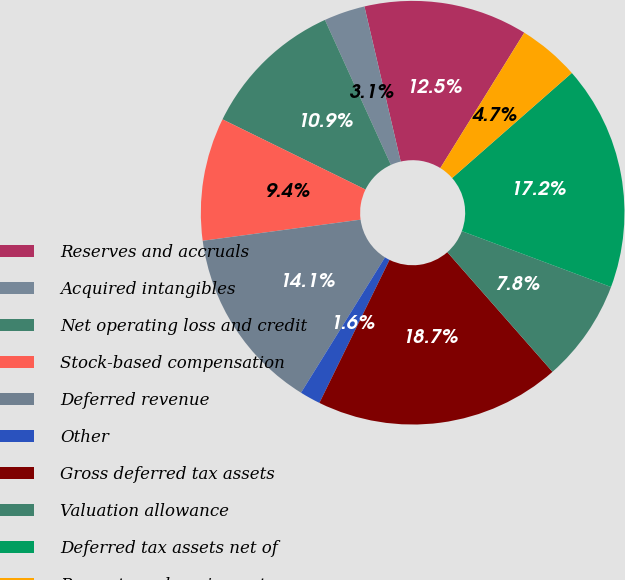Convert chart. <chart><loc_0><loc_0><loc_500><loc_500><pie_chart><fcel>Reserves and accruals<fcel>Acquired intangibles<fcel>Net operating loss and credit<fcel>Stock-based compensation<fcel>Deferred revenue<fcel>Other<fcel>Gross deferred tax assets<fcel>Valuation allowance<fcel>Deferred tax assets net of<fcel>Property and equipment<nl><fcel>12.49%<fcel>3.14%<fcel>10.94%<fcel>9.38%<fcel>14.05%<fcel>1.58%<fcel>18.73%<fcel>7.82%<fcel>17.17%<fcel>4.7%<nl></chart> 